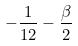Convert formula to latex. <formula><loc_0><loc_0><loc_500><loc_500>- \frac { 1 } { 1 2 } - \frac { \beta } { 2 }</formula> 